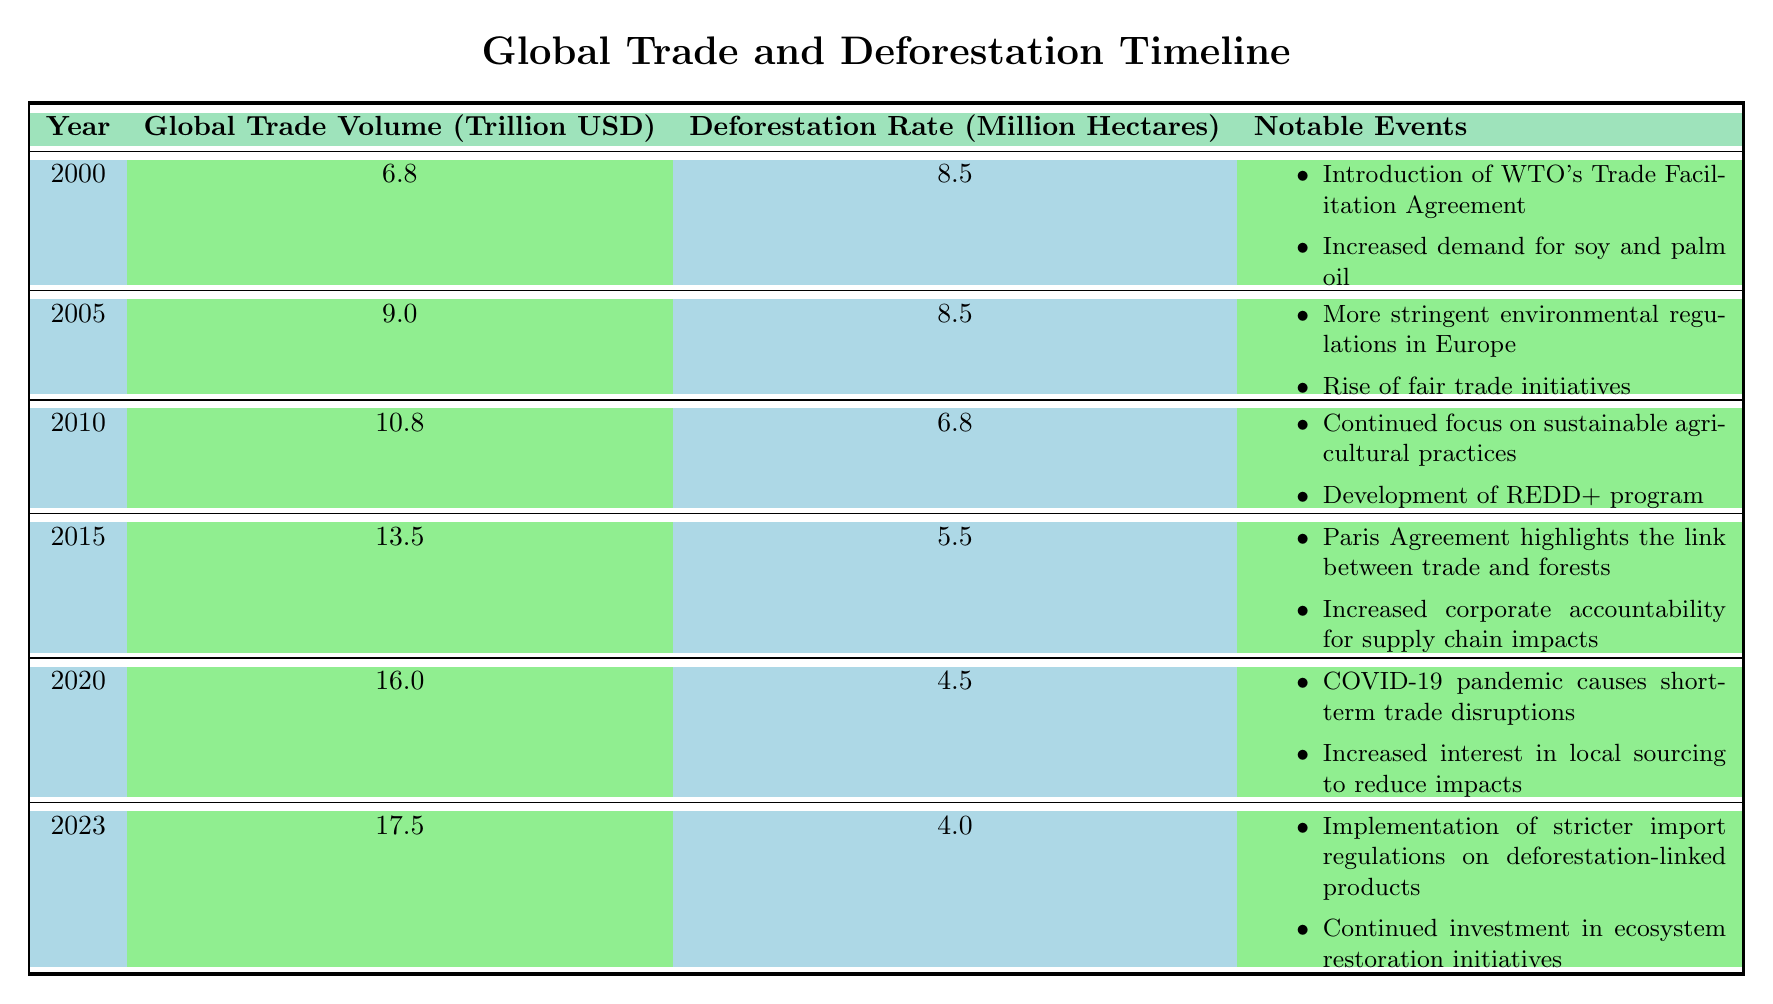What was the global trade volume in 2010? Referring to the table, the row for the year 2010 shows a global trade volume of 10.8 trillion USD.
Answer: 10.8 trillion USD How much did deforestation decrease from 2015 to 2023? Looking at the deforestation rates for 2015 (5.5 million hectares) and 2023 (4.0 million hectares), the decrease is calculated as 5.5 - 4.0 = 1.5 million hectares.
Answer: 1.5 million hectares Did the global trade volume increase every year from 2000 to 2023? Examining the data, all recorded years show an increase in global trade volume from 2000 (6.8 trillion USD) to 2023 (17.5 trillion USD) without any decline in value in between.
Answer: Yes In which year was the deforestation rate the lowest, and what was that rate? Analyzing the deforestation rates in the table, we find that 2023 has the lowest rate at 4.0 million hectares.
Answer: 2023, 4.0 million hectares What was the average deforestation rate from 2000 to 2023? To calculate the average, we sum the deforestation rates from 2000 (8.5) through 2023 (4.0), totaling 139.1 million hectares across 24 years, which gives an average of 139.1 / 24 ≈ 5.79 million hectares.
Answer: Approximately 5.79 million hectares What notable event in 2020 was linked to deforestation? The table mentions that in 2020, the COVID-19 pandemic caused short-term trade disruptions, which likely affected deforestation dynamics.
Answer: COVID-19 pandemic causing trade disruptions Is there evidence of increased corporate accountability after 2015? The data from 2015 mentions increased corporate accountability related to supply chain impacts, and subsequent years show a continued emphasis on sustainability, indicating a trend.
Answer: Yes Which year saw a significant focus on the circular economy, and how did it affect deforestation rates? The year 2016 emphasized circular economy principles, and this period saw a further decline in deforestation rates to 5.3 million hectares, showing a correlation with sustainable practices.
Answer: 2016, 5.3 million hectares 